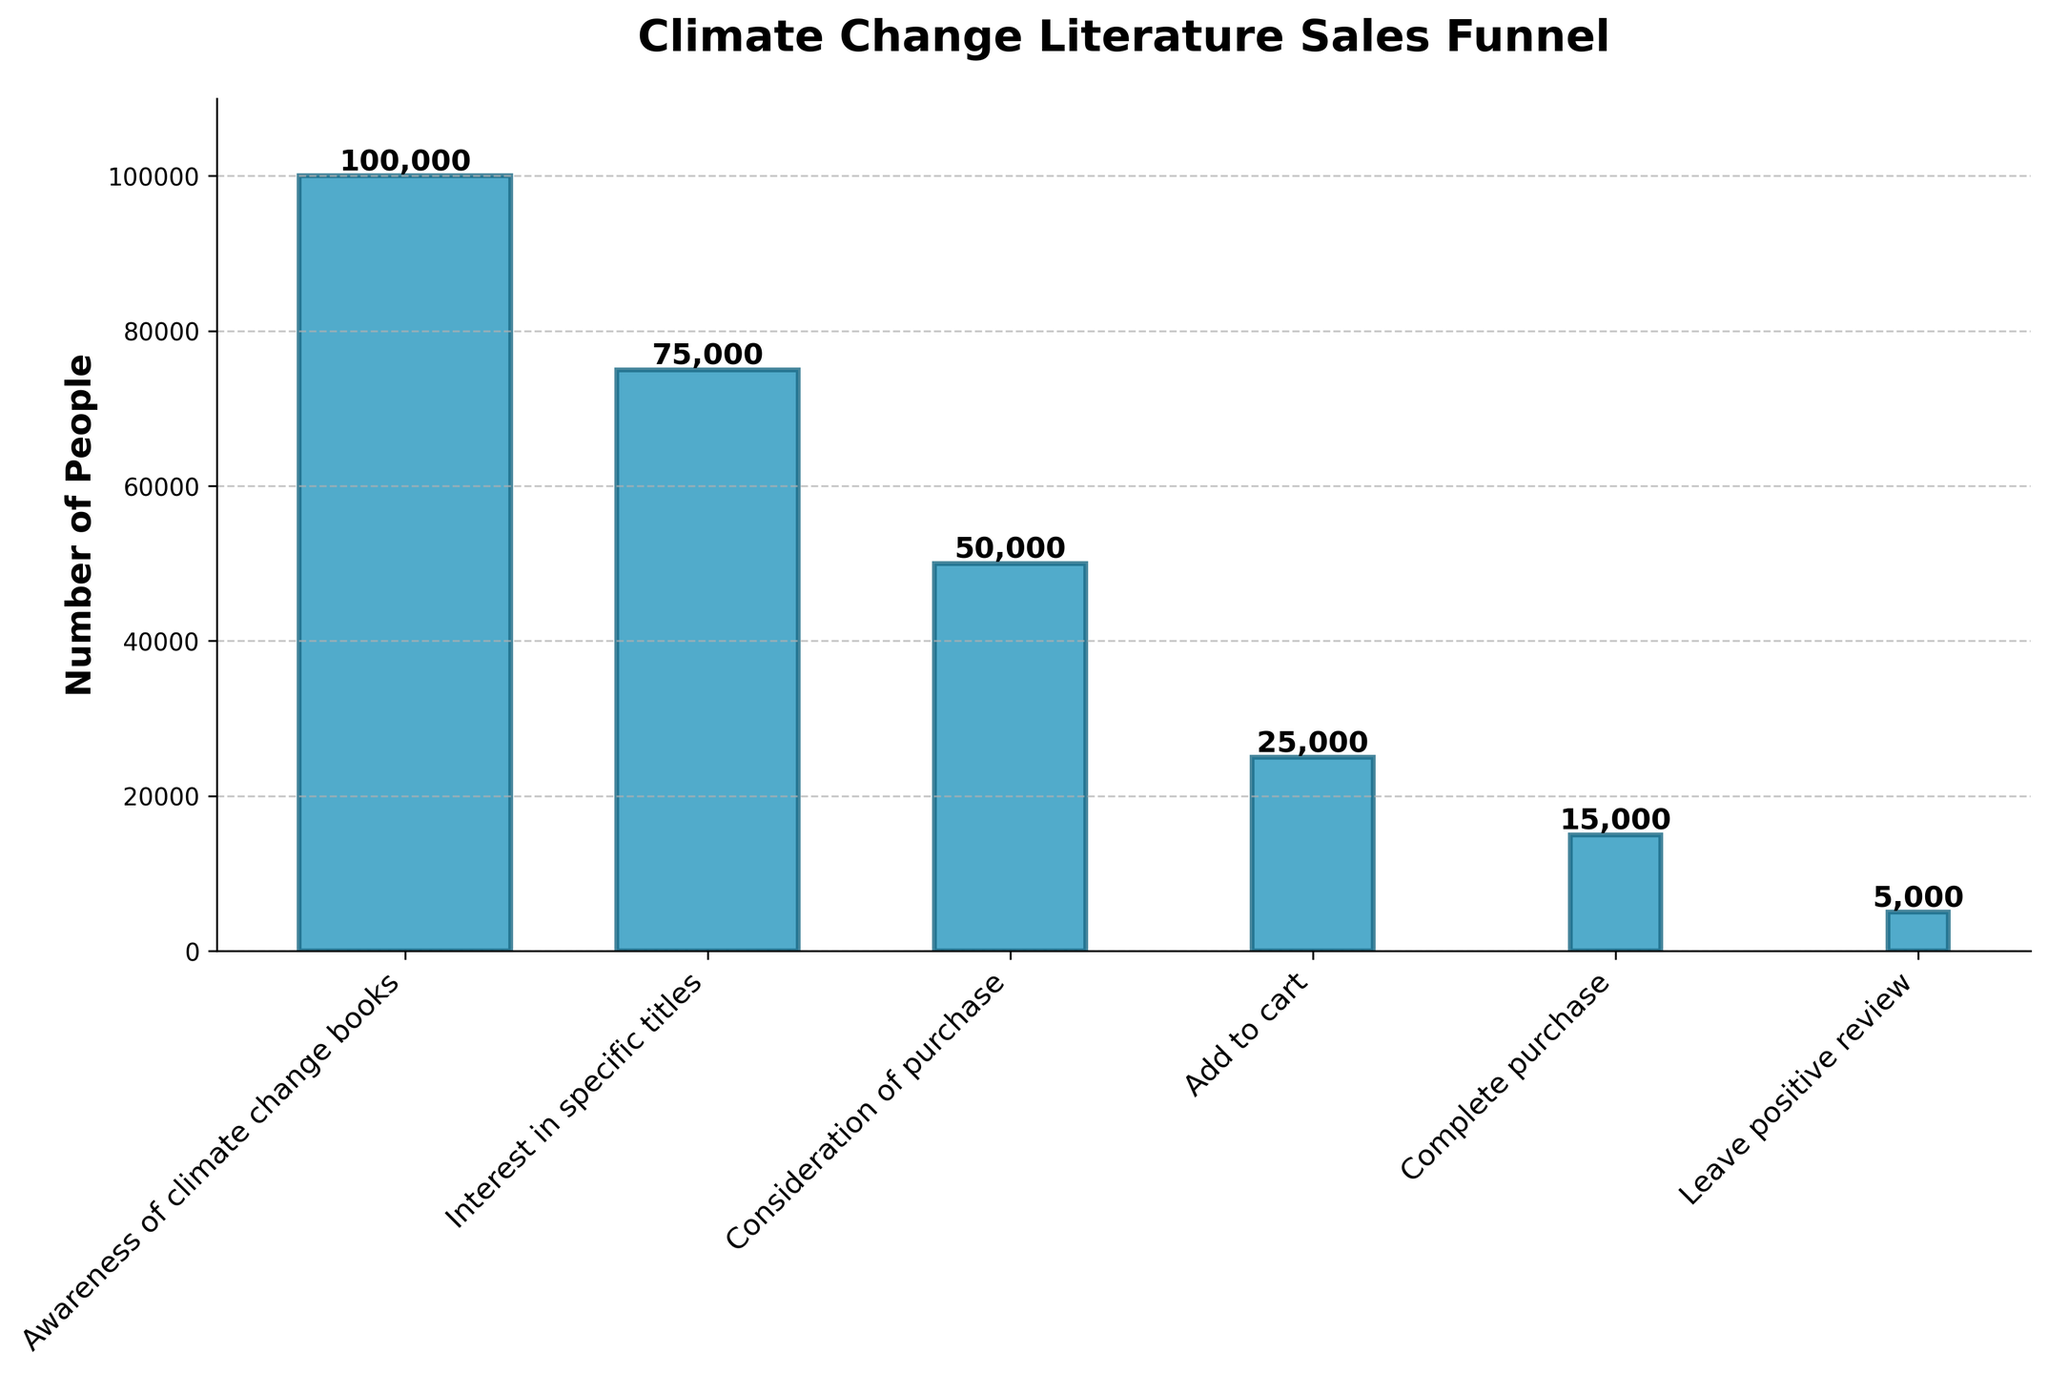What is the title of the chart? The title of the chart is written at the top and often summarizes the main topic of the figure. Here, it reads "Climate Change Literature Sales Funnel".
Answer: Climate Change Literature Sales Funnel How many people completed a purchase of climate change books? The number of people at each stage is marked on the bars in the figure. The bar labeled "Complete purchase" indicates the total number of completed purchases.
Answer: 15,000 Which is the stage with the highest number of people? The figure shows several bars with their corresponding values. The bar labeled "Awareness of climate change books" has the tallest height, indicating the highest number of people.
Answer: Awareness of climate change books What is the difference between the number of people at the "Add to cart" stage and the "Leave positive review" stage? The number of people at the "Add to cart" stage is 25,000, and the number of people at the "Leave positive review" stage is 5,000. Subtracting these gives the difference. Calculation: 25,000 - 5,000 = 20,000.
Answer: 20,000 What percentage of people who showed interest in specific titles ended up completing a purchase? To find this, divide the number of people who completed a purchase by the number of people who showed interest in specific titles, and then multiply by 100. Calculation: (15,000/75,000) * 100 = 20%.
Answer: 20% How many people did not progress from the "Consideration of purchase" stage to the "Add to cart" stage? Subtract the number at the "Add to cart" stage from the number at the "Consideration of purchase" stage. Calculation: 50,000 - 25,000 = 25,000.
Answer: 25,000 At which stage did the number of people halve compared to the previous stage? Look for two consecutive stages where the latter has half the number of people as the former. From "Consideration of purchase" to "Add to cart," the number drops from 50,000 to 25,000, which is a halving.
Answer: Add to cart Which stages show the greatest drop in the number of people? Compare the differences between consecutive stages. The greatest drop occurs between the "Consideration of purchase" stage (50,000) and the "Add to cart" stage (25,000) with a drop of 25,000 people.
Answer: Between "Consideration of purchase" and "Add to cart" Which stage has approximately one-third the number of people as the "Awareness of climate change books" stage? The "Awareness of climate change books" stage has 100,000 people. One-third of this number is approximately 33,333. The "Consideration of purchase" stage has 50,000 people, closest to one-third but not exact.
Answer: Consideration of purchase 